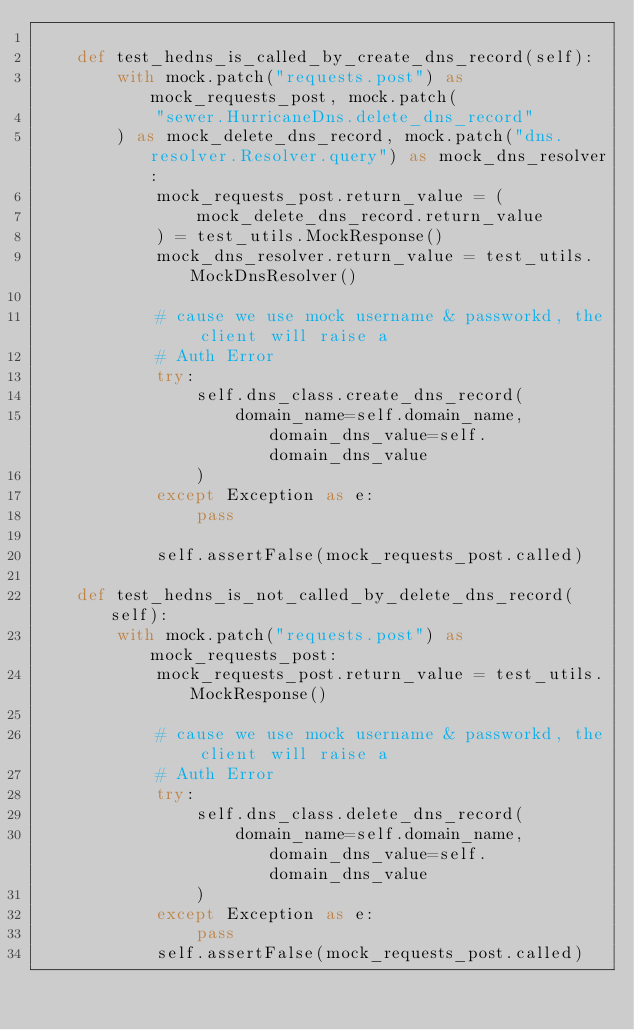Convert code to text. <code><loc_0><loc_0><loc_500><loc_500><_Python_>
    def test_hedns_is_called_by_create_dns_record(self):
        with mock.patch("requests.post") as mock_requests_post, mock.patch(
            "sewer.HurricaneDns.delete_dns_record"
        ) as mock_delete_dns_record, mock.patch("dns.resolver.Resolver.query") as mock_dns_resolver:
            mock_requests_post.return_value = (
                mock_delete_dns_record.return_value
            ) = test_utils.MockResponse()
            mock_dns_resolver.return_value = test_utils.MockDnsResolver()

            # cause we use mock username & passworkd, the client will raise a
            # Auth Error
            try:
                self.dns_class.create_dns_record(
                    domain_name=self.domain_name, domain_dns_value=self.domain_dns_value
                )
            except Exception as e:
                pass

            self.assertFalse(mock_requests_post.called)

    def test_hedns_is_not_called_by_delete_dns_record(self):
        with mock.patch("requests.post") as mock_requests_post:
            mock_requests_post.return_value = test_utils.MockResponse()

            # cause we use mock username & passworkd, the client will raise a
            # Auth Error
            try:
                self.dns_class.delete_dns_record(
                    domain_name=self.domain_name, domain_dns_value=self.domain_dns_value
                )
            except Exception as e:
                pass
            self.assertFalse(mock_requests_post.called)
</code> 